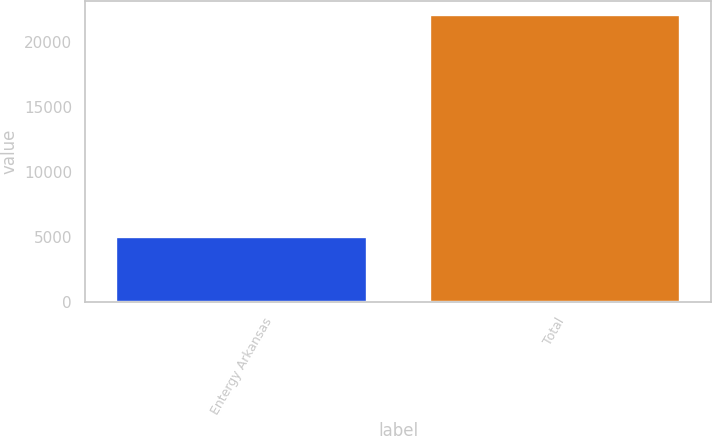Convert chart to OTSL. <chart><loc_0><loc_0><loc_500><loc_500><bar_chart><fcel>Entergy Arkansas<fcel>Total<nl><fcel>4999<fcel>22078<nl></chart> 